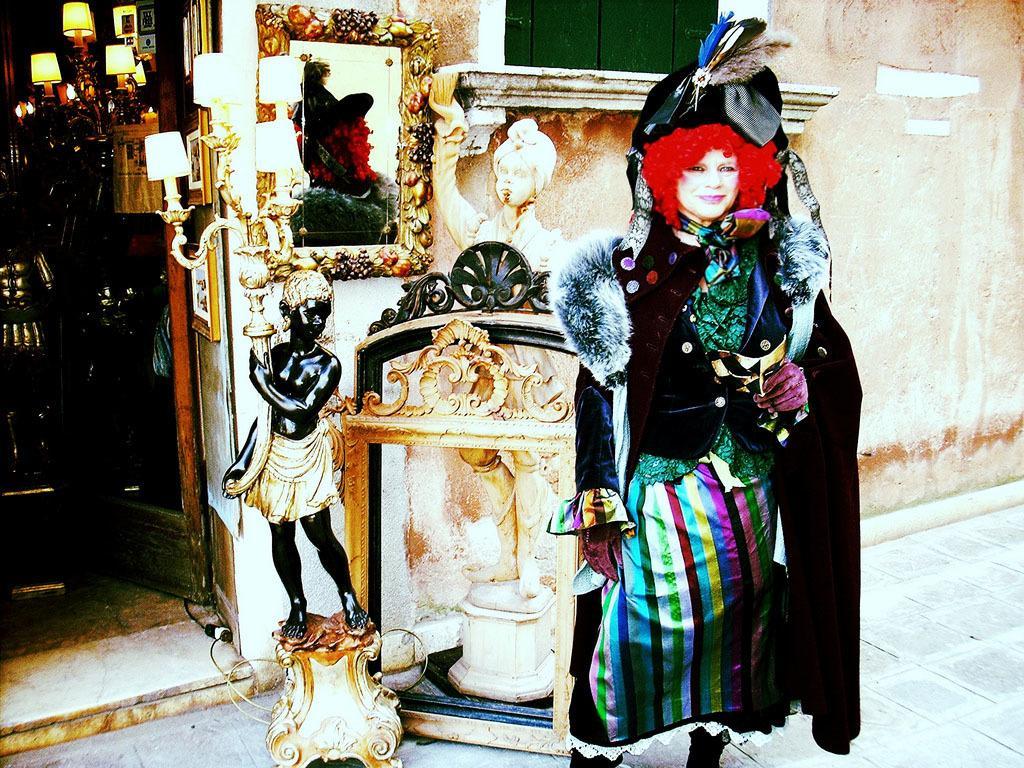Please provide a concise description of this image. In the background we can see the wall, lamps, mirror, frames, sculptures and few objects. In this picture we can see a person wearing a fancy dress and smiling. A person is standing near to a store. 